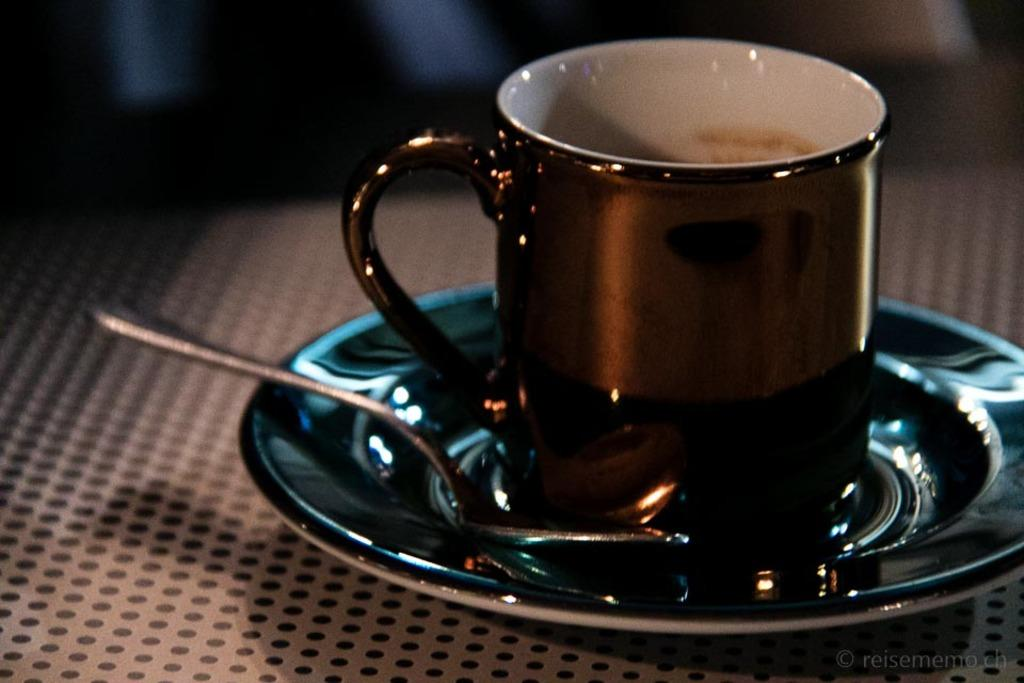What is located in the right bottom corner of the image? There is a cup with a saucer and a spoon in the right bottom corner of the image. What color is the cup in the image? The cup is in brown color. What type of celery can be seen in the image? There is no celery present in the image. What country is depicted in the image? The image does not depict any country; it only shows a cup, saucer, and spoon. 